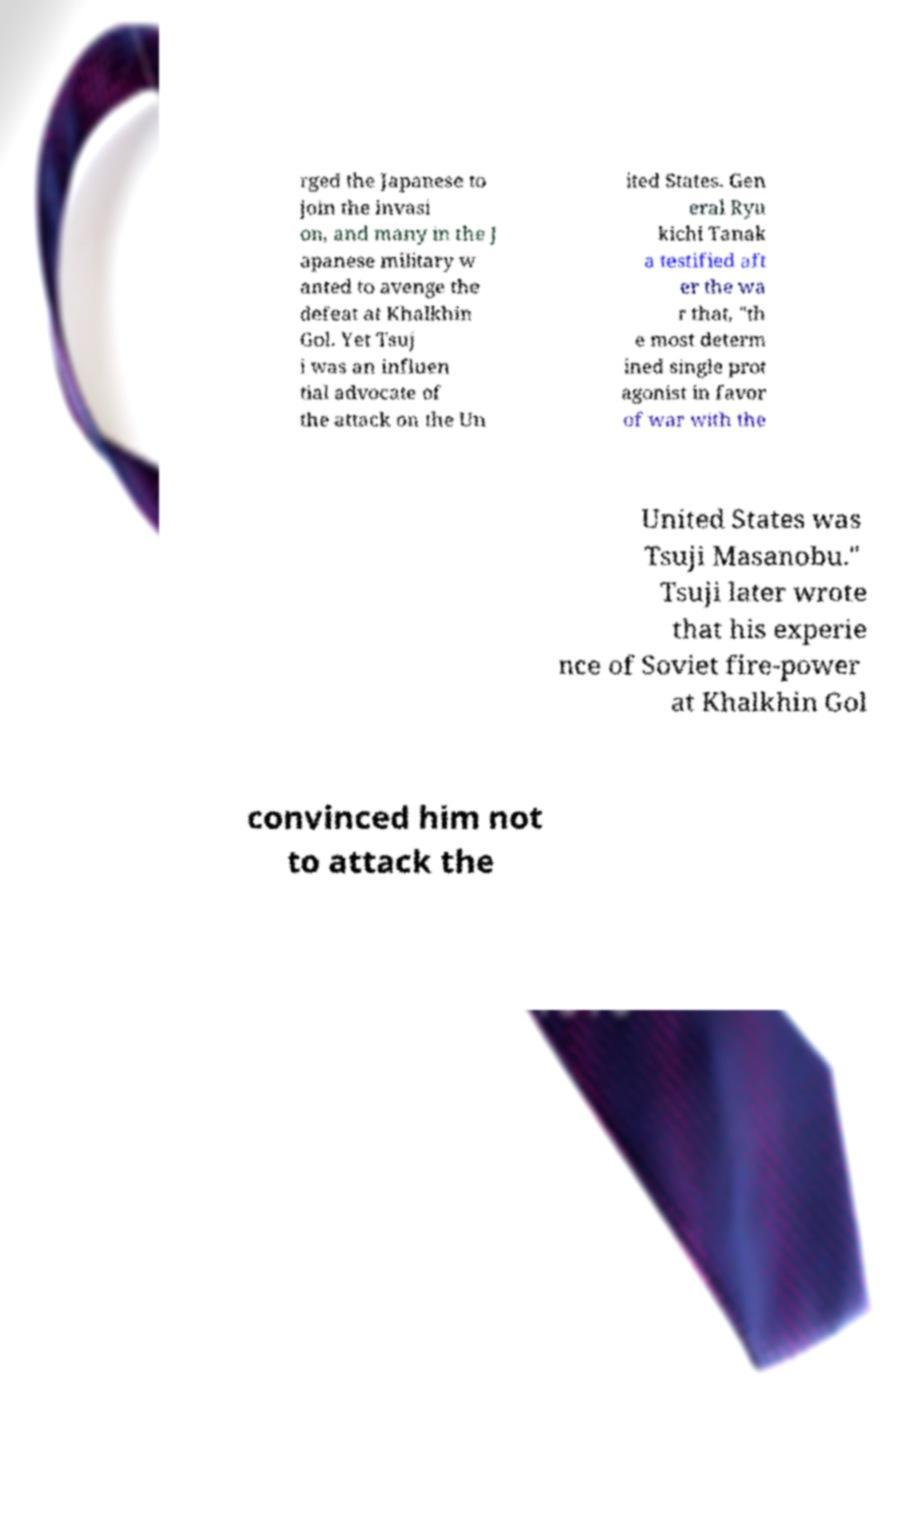What messages or text are displayed in this image? I need them in a readable, typed format. rged the Japanese to join the invasi on, and many in the J apanese military w anted to avenge the defeat at Khalkhin Gol. Yet Tsuj i was an influen tial advocate of the attack on the Un ited States. Gen eral Ryu kichi Tanak a testified aft er the wa r that, "th e most determ ined single prot agonist in favor of war with the United States was Tsuji Masanobu." Tsuji later wrote that his experie nce of Soviet fire-power at Khalkhin Gol convinced him not to attack the 